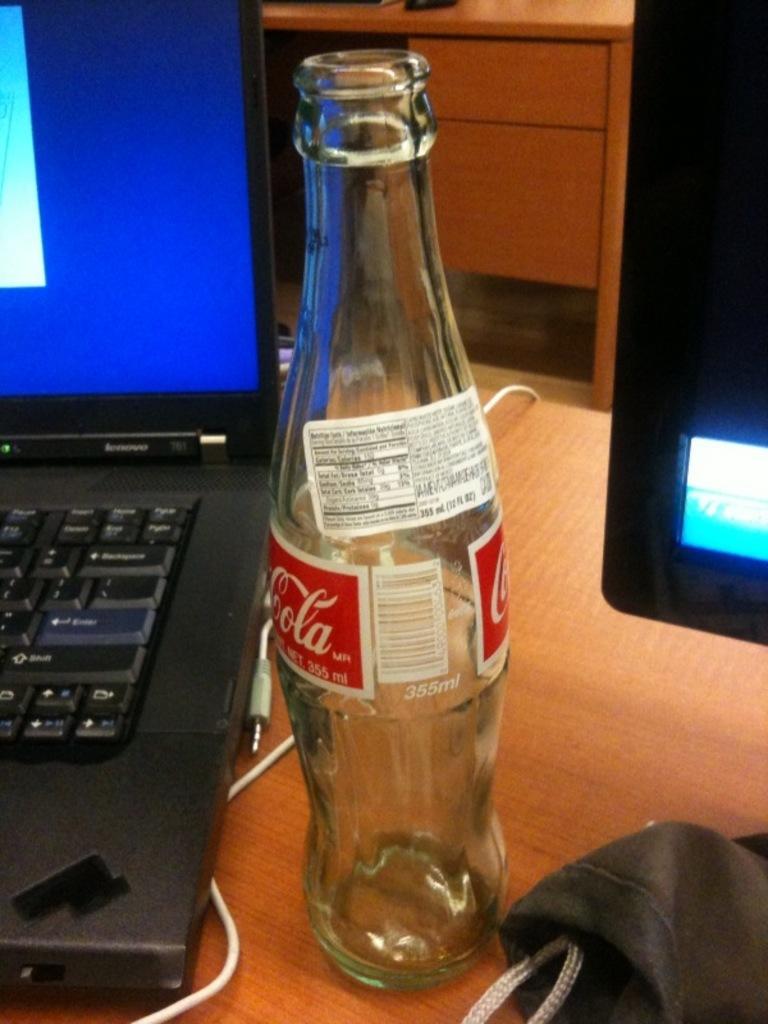Can you describe this image briefly? In this image I can see a glass bottle with white color and a red color sticker is attached to the bottle. On the sticker there is a brand name is written on it. To the left there is a laptop and the wire connectors. To the right there is a system and a cloth on the table. In the back there is a desk. 